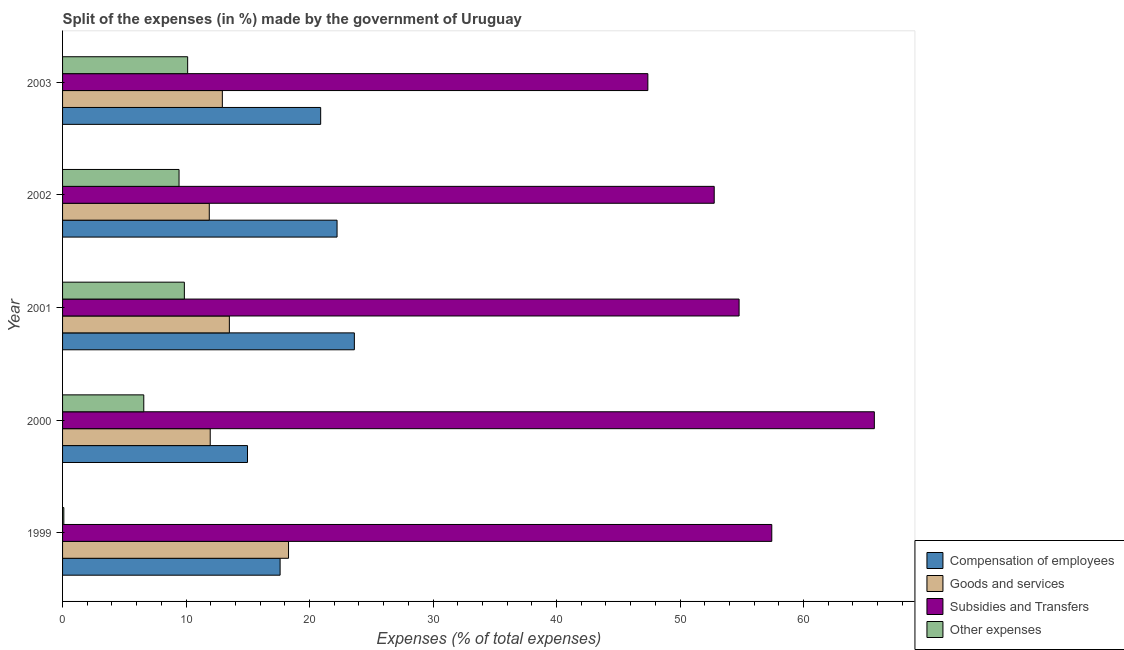How many groups of bars are there?
Your answer should be very brief. 5. Are the number of bars per tick equal to the number of legend labels?
Make the answer very short. Yes. How many bars are there on the 4th tick from the top?
Provide a short and direct response. 4. What is the label of the 2nd group of bars from the top?
Ensure brevity in your answer.  2002. In how many cases, is the number of bars for a given year not equal to the number of legend labels?
Make the answer very short. 0. What is the percentage of amount spent on other expenses in 2000?
Offer a terse response. 6.58. Across all years, what is the maximum percentage of amount spent on other expenses?
Make the answer very short. 10.13. Across all years, what is the minimum percentage of amount spent on other expenses?
Offer a very short reply. 0.1. In which year was the percentage of amount spent on goods and services minimum?
Your answer should be compact. 2002. What is the total percentage of amount spent on compensation of employees in the graph?
Give a very brief answer. 99.34. What is the difference between the percentage of amount spent on goods and services in 2000 and that in 2001?
Keep it short and to the point. -1.55. What is the difference between the percentage of amount spent on other expenses in 2000 and the percentage of amount spent on compensation of employees in 2002?
Offer a terse response. -15.65. What is the average percentage of amount spent on compensation of employees per year?
Your answer should be very brief. 19.87. In the year 2002, what is the difference between the percentage of amount spent on compensation of employees and percentage of amount spent on other expenses?
Keep it short and to the point. 12.79. Is the difference between the percentage of amount spent on goods and services in 1999 and 2003 greater than the difference between the percentage of amount spent on other expenses in 1999 and 2003?
Keep it short and to the point. Yes. What is the difference between the highest and the second highest percentage of amount spent on compensation of employees?
Make the answer very short. 1.4. What is the difference between the highest and the lowest percentage of amount spent on compensation of employees?
Offer a very short reply. 8.65. What does the 4th bar from the top in 2002 represents?
Provide a succinct answer. Compensation of employees. What does the 2nd bar from the bottom in 2000 represents?
Provide a succinct answer. Goods and services. How many bars are there?
Your answer should be very brief. 20. Are all the bars in the graph horizontal?
Keep it short and to the point. Yes. Are the values on the major ticks of X-axis written in scientific E-notation?
Your answer should be very brief. No. Does the graph contain any zero values?
Your answer should be compact. No. Does the graph contain grids?
Provide a short and direct response. No. Where does the legend appear in the graph?
Provide a short and direct response. Bottom right. How are the legend labels stacked?
Make the answer very short. Vertical. What is the title of the graph?
Keep it short and to the point. Split of the expenses (in %) made by the government of Uruguay. What is the label or title of the X-axis?
Ensure brevity in your answer.  Expenses (% of total expenses). What is the Expenses (% of total expenses) of Compensation of employees in 1999?
Ensure brevity in your answer.  17.61. What is the Expenses (% of total expenses) of Goods and services in 1999?
Ensure brevity in your answer.  18.3. What is the Expenses (% of total expenses) in Subsidies and Transfers in 1999?
Provide a succinct answer. 57.43. What is the Expenses (% of total expenses) in Other expenses in 1999?
Your answer should be very brief. 0.1. What is the Expenses (% of total expenses) of Compensation of employees in 2000?
Keep it short and to the point. 14.97. What is the Expenses (% of total expenses) of Goods and services in 2000?
Your response must be concise. 11.96. What is the Expenses (% of total expenses) of Subsidies and Transfers in 2000?
Provide a short and direct response. 65.73. What is the Expenses (% of total expenses) of Other expenses in 2000?
Ensure brevity in your answer.  6.58. What is the Expenses (% of total expenses) of Compensation of employees in 2001?
Offer a very short reply. 23.63. What is the Expenses (% of total expenses) of Goods and services in 2001?
Your answer should be very brief. 13.51. What is the Expenses (% of total expenses) in Subsidies and Transfers in 2001?
Give a very brief answer. 54.78. What is the Expenses (% of total expenses) of Other expenses in 2001?
Offer a terse response. 9.86. What is the Expenses (% of total expenses) in Compensation of employees in 2002?
Ensure brevity in your answer.  22.23. What is the Expenses (% of total expenses) of Goods and services in 2002?
Keep it short and to the point. 11.88. What is the Expenses (% of total expenses) in Subsidies and Transfers in 2002?
Make the answer very short. 52.77. What is the Expenses (% of total expenses) of Other expenses in 2002?
Make the answer very short. 9.43. What is the Expenses (% of total expenses) in Compensation of employees in 2003?
Your answer should be compact. 20.9. What is the Expenses (% of total expenses) of Goods and services in 2003?
Provide a succinct answer. 12.94. What is the Expenses (% of total expenses) in Subsidies and Transfers in 2003?
Provide a short and direct response. 47.39. What is the Expenses (% of total expenses) in Other expenses in 2003?
Provide a succinct answer. 10.13. Across all years, what is the maximum Expenses (% of total expenses) of Compensation of employees?
Provide a succinct answer. 23.63. Across all years, what is the maximum Expenses (% of total expenses) in Goods and services?
Offer a very short reply. 18.3. Across all years, what is the maximum Expenses (% of total expenses) of Subsidies and Transfers?
Your answer should be compact. 65.73. Across all years, what is the maximum Expenses (% of total expenses) of Other expenses?
Offer a very short reply. 10.13. Across all years, what is the minimum Expenses (% of total expenses) of Compensation of employees?
Make the answer very short. 14.97. Across all years, what is the minimum Expenses (% of total expenses) of Goods and services?
Your answer should be compact. 11.88. Across all years, what is the minimum Expenses (% of total expenses) of Subsidies and Transfers?
Your answer should be very brief. 47.39. Across all years, what is the minimum Expenses (% of total expenses) in Other expenses?
Ensure brevity in your answer.  0.1. What is the total Expenses (% of total expenses) in Compensation of employees in the graph?
Your response must be concise. 99.34. What is the total Expenses (% of total expenses) of Goods and services in the graph?
Provide a short and direct response. 68.58. What is the total Expenses (% of total expenses) in Subsidies and Transfers in the graph?
Offer a very short reply. 278.09. What is the total Expenses (% of total expenses) of Other expenses in the graph?
Your answer should be very brief. 36.1. What is the difference between the Expenses (% of total expenses) of Compensation of employees in 1999 and that in 2000?
Provide a short and direct response. 2.64. What is the difference between the Expenses (% of total expenses) in Goods and services in 1999 and that in 2000?
Ensure brevity in your answer.  6.34. What is the difference between the Expenses (% of total expenses) in Subsidies and Transfers in 1999 and that in 2000?
Make the answer very short. -8.3. What is the difference between the Expenses (% of total expenses) of Other expenses in 1999 and that in 2000?
Your answer should be very brief. -6.47. What is the difference between the Expenses (% of total expenses) of Compensation of employees in 1999 and that in 2001?
Provide a succinct answer. -6.01. What is the difference between the Expenses (% of total expenses) in Goods and services in 1999 and that in 2001?
Offer a terse response. 4.79. What is the difference between the Expenses (% of total expenses) in Subsidies and Transfers in 1999 and that in 2001?
Your answer should be very brief. 2.65. What is the difference between the Expenses (% of total expenses) in Other expenses in 1999 and that in 2001?
Give a very brief answer. -9.76. What is the difference between the Expenses (% of total expenses) in Compensation of employees in 1999 and that in 2002?
Provide a succinct answer. -4.61. What is the difference between the Expenses (% of total expenses) of Goods and services in 1999 and that in 2002?
Your answer should be very brief. 6.42. What is the difference between the Expenses (% of total expenses) of Subsidies and Transfers in 1999 and that in 2002?
Provide a succinct answer. 4.66. What is the difference between the Expenses (% of total expenses) in Other expenses in 1999 and that in 2002?
Your answer should be compact. -9.33. What is the difference between the Expenses (% of total expenses) of Compensation of employees in 1999 and that in 2003?
Offer a terse response. -3.29. What is the difference between the Expenses (% of total expenses) of Goods and services in 1999 and that in 2003?
Offer a terse response. 5.36. What is the difference between the Expenses (% of total expenses) in Subsidies and Transfers in 1999 and that in 2003?
Ensure brevity in your answer.  10.03. What is the difference between the Expenses (% of total expenses) of Other expenses in 1999 and that in 2003?
Keep it short and to the point. -10.03. What is the difference between the Expenses (% of total expenses) of Compensation of employees in 2000 and that in 2001?
Your answer should be compact. -8.65. What is the difference between the Expenses (% of total expenses) of Goods and services in 2000 and that in 2001?
Offer a very short reply. -1.55. What is the difference between the Expenses (% of total expenses) of Subsidies and Transfers in 2000 and that in 2001?
Make the answer very short. 10.95. What is the difference between the Expenses (% of total expenses) in Other expenses in 2000 and that in 2001?
Your answer should be compact. -3.29. What is the difference between the Expenses (% of total expenses) in Compensation of employees in 2000 and that in 2002?
Offer a very short reply. -7.25. What is the difference between the Expenses (% of total expenses) of Goods and services in 2000 and that in 2002?
Offer a terse response. 0.08. What is the difference between the Expenses (% of total expenses) in Subsidies and Transfers in 2000 and that in 2002?
Provide a short and direct response. 12.96. What is the difference between the Expenses (% of total expenses) in Other expenses in 2000 and that in 2002?
Ensure brevity in your answer.  -2.85. What is the difference between the Expenses (% of total expenses) in Compensation of employees in 2000 and that in 2003?
Your response must be concise. -5.93. What is the difference between the Expenses (% of total expenses) of Goods and services in 2000 and that in 2003?
Make the answer very short. -0.98. What is the difference between the Expenses (% of total expenses) of Subsidies and Transfers in 2000 and that in 2003?
Your answer should be compact. 18.34. What is the difference between the Expenses (% of total expenses) in Other expenses in 2000 and that in 2003?
Provide a short and direct response. -3.55. What is the difference between the Expenses (% of total expenses) in Compensation of employees in 2001 and that in 2002?
Keep it short and to the point. 1.4. What is the difference between the Expenses (% of total expenses) in Goods and services in 2001 and that in 2002?
Your answer should be very brief. 1.63. What is the difference between the Expenses (% of total expenses) of Subsidies and Transfers in 2001 and that in 2002?
Your answer should be very brief. 2.01. What is the difference between the Expenses (% of total expenses) in Other expenses in 2001 and that in 2002?
Provide a short and direct response. 0.43. What is the difference between the Expenses (% of total expenses) in Compensation of employees in 2001 and that in 2003?
Give a very brief answer. 2.73. What is the difference between the Expenses (% of total expenses) in Goods and services in 2001 and that in 2003?
Make the answer very short. 0.57. What is the difference between the Expenses (% of total expenses) of Subsidies and Transfers in 2001 and that in 2003?
Your answer should be very brief. 7.39. What is the difference between the Expenses (% of total expenses) of Other expenses in 2001 and that in 2003?
Your response must be concise. -0.27. What is the difference between the Expenses (% of total expenses) in Compensation of employees in 2002 and that in 2003?
Provide a succinct answer. 1.33. What is the difference between the Expenses (% of total expenses) in Goods and services in 2002 and that in 2003?
Offer a very short reply. -1.06. What is the difference between the Expenses (% of total expenses) in Subsidies and Transfers in 2002 and that in 2003?
Offer a terse response. 5.37. What is the difference between the Expenses (% of total expenses) in Other expenses in 2002 and that in 2003?
Give a very brief answer. -0.7. What is the difference between the Expenses (% of total expenses) of Compensation of employees in 1999 and the Expenses (% of total expenses) of Goods and services in 2000?
Offer a terse response. 5.66. What is the difference between the Expenses (% of total expenses) of Compensation of employees in 1999 and the Expenses (% of total expenses) of Subsidies and Transfers in 2000?
Offer a terse response. -48.12. What is the difference between the Expenses (% of total expenses) of Compensation of employees in 1999 and the Expenses (% of total expenses) of Other expenses in 2000?
Your answer should be very brief. 11.04. What is the difference between the Expenses (% of total expenses) of Goods and services in 1999 and the Expenses (% of total expenses) of Subsidies and Transfers in 2000?
Offer a very short reply. -47.43. What is the difference between the Expenses (% of total expenses) in Goods and services in 1999 and the Expenses (% of total expenses) in Other expenses in 2000?
Offer a terse response. 11.72. What is the difference between the Expenses (% of total expenses) of Subsidies and Transfers in 1999 and the Expenses (% of total expenses) of Other expenses in 2000?
Offer a terse response. 50.85. What is the difference between the Expenses (% of total expenses) of Compensation of employees in 1999 and the Expenses (% of total expenses) of Goods and services in 2001?
Provide a short and direct response. 4.11. What is the difference between the Expenses (% of total expenses) of Compensation of employees in 1999 and the Expenses (% of total expenses) of Subsidies and Transfers in 2001?
Provide a succinct answer. -37.17. What is the difference between the Expenses (% of total expenses) in Compensation of employees in 1999 and the Expenses (% of total expenses) in Other expenses in 2001?
Offer a terse response. 7.75. What is the difference between the Expenses (% of total expenses) in Goods and services in 1999 and the Expenses (% of total expenses) in Subsidies and Transfers in 2001?
Make the answer very short. -36.48. What is the difference between the Expenses (% of total expenses) in Goods and services in 1999 and the Expenses (% of total expenses) in Other expenses in 2001?
Provide a short and direct response. 8.44. What is the difference between the Expenses (% of total expenses) in Subsidies and Transfers in 1999 and the Expenses (% of total expenses) in Other expenses in 2001?
Offer a very short reply. 47.56. What is the difference between the Expenses (% of total expenses) of Compensation of employees in 1999 and the Expenses (% of total expenses) of Goods and services in 2002?
Provide a succinct answer. 5.74. What is the difference between the Expenses (% of total expenses) in Compensation of employees in 1999 and the Expenses (% of total expenses) in Subsidies and Transfers in 2002?
Your answer should be very brief. -35.15. What is the difference between the Expenses (% of total expenses) in Compensation of employees in 1999 and the Expenses (% of total expenses) in Other expenses in 2002?
Ensure brevity in your answer.  8.18. What is the difference between the Expenses (% of total expenses) of Goods and services in 1999 and the Expenses (% of total expenses) of Subsidies and Transfers in 2002?
Make the answer very short. -34.47. What is the difference between the Expenses (% of total expenses) in Goods and services in 1999 and the Expenses (% of total expenses) in Other expenses in 2002?
Provide a succinct answer. 8.87. What is the difference between the Expenses (% of total expenses) in Subsidies and Transfers in 1999 and the Expenses (% of total expenses) in Other expenses in 2002?
Make the answer very short. 48. What is the difference between the Expenses (% of total expenses) in Compensation of employees in 1999 and the Expenses (% of total expenses) in Goods and services in 2003?
Provide a succinct answer. 4.68. What is the difference between the Expenses (% of total expenses) of Compensation of employees in 1999 and the Expenses (% of total expenses) of Subsidies and Transfers in 2003?
Give a very brief answer. -29.78. What is the difference between the Expenses (% of total expenses) of Compensation of employees in 1999 and the Expenses (% of total expenses) of Other expenses in 2003?
Give a very brief answer. 7.49. What is the difference between the Expenses (% of total expenses) in Goods and services in 1999 and the Expenses (% of total expenses) in Subsidies and Transfers in 2003?
Offer a terse response. -29.09. What is the difference between the Expenses (% of total expenses) of Goods and services in 1999 and the Expenses (% of total expenses) of Other expenses in 2003?
Your response must be concise. 8.17. What is the difference between the Expenses (% of total expenses) in Subsidies and Transfers in 1999 and the Expenses (% of total expenses) in Other expenses in 2003?
Keep it short and to the point. 47.3. What is the difference between the Expenses (% of total expenses) in Compensation of employees in 2000 and the Expenses (% of total expenses) in Goods and services in 2001?
Make the answer very short. 1.47. What is the difference between the Expenses (% of total expenses) of Compensation of employees in 2000 and the Expenses (% of total expenses) of Subsidies and Transfers in 2001?
Provide a succinct answer. -39.81. What is the difference between the Expenses (% of total expenses) in Compensation of employees in 2000 and the Expenses (% of total expenses) in Other expenses in 2001?
Provide a succinct answer. 5.11. What is the difference between the Expenses (% of total expenses) of Goods and services in 2000 and the Expenses (% of total expenses) of Subsidies and Transfers in 2001?
Offer a very short reply. -42.82. What is the difference between the Expenses (% of total expenses) in Goods and services in 2000 and the Expenses (% of total expenses) in Other expenses in 2001?
Your answer should be compact. 2.09. What is the difference between the Expenses (% of total expenses) of Subsidies and Transfers in 2000 and the Expenses (% of total expenses) of Other expenses in 2001?
Keep it short and to the point. 55.87. What is the difference between the Expenses (% of total expenses) of Compensation of employees in 2000 and the Expenses (% of total expenses) of Goods and services in 2002?
Offer a very short reply. 3.09. What is the difference between the Expenses (% of total expenses) in Compensation of employees in 2000 and the Expenses (% of total expenses) in Subsidies and Transfers in 2002?
Keep it short and to the point. -37.79. What is the difference between the Expenses (% of total expenses) in Compensation of employees in 2000 and the Expenses (% of total expenses) in Other expenses in 2002?
Offer a very short reply. 5.54. What is the difference between the Expenses (% of total expenses) of Goods and services in 2000 and the Expenses (% of total expenses) of Subsidies and Transfers in 2002?
Give a very brief answer. -40.81. What is the difference between the Expenses (% of total expenses) in Goods and services in 2000 and the Expenses (% of total expenses) in Other expenses in 2002?
Offer a very short reply. 2.52. What is the difference between the Expenses (% of total expenses) in Subsidies and Transfers in 2000 and the Expenses (% of total expenses) in Other expenses in 2002?
Your answer should be very brief. 56.3. What is the difference between the Expenses (% of total expenses) of Compensation of employees in 2000 and the Expenses (% of total expenses) of Goods and services in 2003?
Give a very brief answer. 2.04. What is the difference between the Expenses (% of total expenses) of Compensation of employees in 2000 and the Expenses (% of total expenses) of Subsidies and Transfers in 2003?
Provide a short and direct response. -32.42. What is the difference between the Expenses (% of total expenses) of Compensation of employees in 2000 and the Expenses (% of total expenses) of Other expenses in 2003?
Offer a very short reply. 4.84. What is the difference between the Expenses (% of total expenses) of Goods and services in 2000 and the Expenses (% of total expenses) of Subsidies and Transfers in 2003?
Your response must be concise. -35.44. What is the difference between the Expenses (% of total expenses) of Goods and services in 2000 and the Expenses (% of total expenses) of Other expenses in 2003?
Provide a succinct answer. 1.83. What is the difference between the Expenses (% of total expenses) in Subsidies and Transfers in 2000 and the Expenses (% of total expenses) in Other expenses in 2003?
Your answer should be very brief. 55.6. What is the difference between the Expenses (% of total expenses) of Compensation of employees in 2001 and the Expenses (% of total expenses) of Goods and services in 2002?
Your response must be concise. 11.75. What is the difference between the Expenses (% of total expenses) in Compensation of employees in 2001 and the Expenses (% of total expenses) in Subsidies and Transfers in 2002?
Offer a terse response. -29.14. What is the difference between the Expenses (% of total expenses) in Compensation of employees in 2001 and the Expenses (% of total expenses) in Other expenses in 2002?
Your response must be concise. 14.2. What is the difference between the Expenses (% of total expenses) of Goods and services in 2001 and the Expenses (% of total expenses) of Subsidies and Transfers in 2002?
Your answer should be very brief. -39.26. What is the difference between the Expenses (% of total expenses) in Goods and services in 2001 and the Expenses (% of total expenses) in Other expenses in 2002?
Your response must be concise. 4.07. What is the difference between the Expenses (% of total expenses) of Subsidies and Transfers in 2001 and the Expenses (% of total expenses) of Other expenses in 2002?
Ensure brevity in your answer.  45.35. What is the difference between the Expenses (% of total expenses) of Compensation of employees in 2001 and the Expenses (% of total expenses) of Goods and services in 2003?
Your answer should be compact. 10.69. What is the difference between the Expenses (% of total expenses) of Compensation of employees in 2001 and the Expenses (% of total expenses) of Subsidies and Transfers in 2003?
Keep it short and to the point. -23.76. What is the difference between the Expenses (% of total expenses) in Compensation of employees in 2001 and the Expenses (% of total expenses) in Other expenses in 2003?
Give a very brief answer. 13.5. What is the difference between the Expenses (% of total expenses) in Goods and services in 2001 and the Expenses (% of total expenses) in Subsidies and Transfers in 2003?
Your answer should be very brief. -33.89. What is the difference between the Expenses (% of total expenses) in Goods and services in 2001 and the Expenses (% of total expenses) in Other expenses in 2003?
Keep it short and to the point. 3.38. What is the difference between the Expenses (% of total expenses) of Subsidies and Transfers in 2001 and the Expenses (% of total expenses) of Other expenses in 2003?
Offer a terse response. 44.65. What is the difference between the Expenses (% of total expenses) in Compensation of employees in 2002 and the Expenses (% of total expenses) in Goods and services in 2003?
Ensure brevity in your answer.  9.29. What is the difference between the Expenses (% of total expenses) in Compensation of employees in 2002 and the Expenses (% of total expenses) in Subsidies and Transfers in 2003?
Ensure brevity in your answer.  -25.17. What is the difference between the Expenses (% of total expenses) in Compensation of employees in 2002 and the Expenses (% of total expenses) in Other expenses in 2003?
Offer a very short reply. 12.1. What is the difference between the Expenses (% of total expenses) of Goods and services in 2002 and the Expenses (% of total expenses) of Subsidies and Transfers in 2003?
Your response must be concise. -35.51. What is the difference between the Expenses (% of total expenses) in Goods and services in 2002 and the Expenses (% of total expenses) in Other expenses in 2003?
Provide a short and direct response. 1.75. What is the difference between the Expenses (% of total expenses) of Subsidies and Transfers in 2002 and the Expenses (% of total expenses) of Other expenses in 2003?
Offer a very short reply. 42.64. What is the average Expenses (% of total expenses) of Compensation of employees per year?
Provide a succinct answer. 19.87. What is the average Expenses (% of total expenses) in Goods and services per year?
Provide a short and direct response. 13.72. What is the average Expenses (% of total expenses) of Subsidies and Transfers per year?
Give a very brief answer. 55.62. What is the average Expenses (% of total expenses) of Other expenses per year?
Provide a short and direct response. 7.22. In the year 1999, what is the difference between the Expenses (% of total expenses) of Compensation of employees and Expenses (% of total expenses) of Goods and services?
Your answer should be very brief. -0.68. In the year 1999, what is the difference between the Expenses (% of total expenses) of Compensation of employees and Expenses (% of total expenses) of Subsidies and Transfers?
Your answer should be compact. -39.81. In the year 1999, what is the difference between the Expenses (% of total expenses) in Compensation of employees and Expenses (% of total expenses) in Other expenses?
Your answer should be compact. 17.51. In the year 1999, what is the difference between the Expenses (% of total expenses) in Goods and services and Expenses (% of total expenses) in Subsidies and Transfers?
Provide a succinct answer. -39.13. In the year 1999, what is the difference between the Expenses (% of total expenses) of Goods and services and Expenses (% of total expenses) of Other expenses?
Provide a short and direct response. 18.19. In the year 1999, what is the difference between the Expenses (% of total expenses) in Subsidies and Transfers and Expenses (% of total expenses) in Other expenses?
Offer a very short reply. 57.32. In the year 2000, what is the difference between the Expenses (% of total expenses) in Compensation of employees and Expenses (% of total expenses) in Goods and services?
Your answer should be very brief. 3.02. In the year 2000, what is the difference between the Expenses (% of total expenses) in Compensation of employees and Expenses (% of total expenses) in Subsidies and Transfers?
Give a very brief answer. -50.76. In the year 2000, what is the difference between the Expenses (% of total expenses) in Compensation of employees and Expenses (% of total expenses) in Other expenses?
Provide a short and direct response. 8.4. In the year 2000, what is the difference between the Expenses (% of total expenses) of Goods and services and Expenses (% of total expenses) of Subsidies and Transfers?
Your response must be concise. -53.77. In the year 2000, what is the difference between the Expenses (% of total expenses) of Goods and services and Expenses (% of total expenses) of Other expenses?
Your response must be concise. 5.38. In the year 2000, what is the difference between the Expenses (% of total expenses) of Subsidies and Transfers and Expenses (% of total expenses) of Other expenses?
Ensure brevity in your answer.  59.15. In the year 2001, what is the difference between the Expenses (% of total expenses) of Compensation of employees and Expenses (% of total expenses) of Goods and services?
Your answer should be compact. 10.12. In the year 2001, what is the difference between the Expenses (% of total expenses) of Compensation of employees and Expenses (% of total expenses) of Subsidies and Transfers?
Ensure brevity in your answer.  -31.15. In the year 2001, what is the difference between the Expenses (% of total expenses) of Compensation of employees and Expenses (% of total expenses) of Other expenses?
Your answer should be very brief. 13.77. In the year 2001, what is the difference between the Expenses (% of total expenses) of Goods and services and Expenses (% of total expenses) of Subsidies and Transfers?
Offer a very short reply. -41.27. In the year 2001, what is the difference between the Expenses (% of total expenses) of Goods and services and Expenses (% of total expenses) of Other expenses?
Your answer should be compact. 3.64. In the year 2001, what is the difference between the Expenses (% of total expenses) in Subsidies and Transfers and Expenses (% of total expenses) in Other expenses?
Offer a terse response. 44.92. In the year 2002, what is the difference between the Expenses (% of total expenses) of Compensation of employees and Expenses (% of total expenses) of Goods and services?
Provide a short and direct response. 10.35. In the year 2002, what is the difference between the Expenses (% of total expenses) in Compensation of employees and Expenses (% of total expenses) in Subsidies and Transfers?
Give a very brief answer. -30.54. In the year 2002, what is the difference between the Expenses (% of total expenses) in Compensation of employees and Expenses (% of total expenses) in Other expenses?
Ensure brevity in your answer.  12.79. In the year 2002, what is the difference between the Expenses (% of total expenses) of Goods and services and Expenses (% of total expenses) of Subsidies and Transfers?
Provide a succinct answer. -40.89. In the year 2002, what is the difference between the Expenses (% of total expenses) in Goods and services and Expenses (% of total expenses) in Other expenses?
Provide a short and direct response. 2.45. In the year 2002, what is the difference between the Expenses (% of total expenses) in Subsidies and Transfers and Expenses (% of total expenses) in Other expenses?
Your response must be concise. 43.33. In the year 2003, what is the difference between the Expenses (% of total expenses) in Compensation of employees and Expenses (% of total expenses) in Goods and services?
Offer a very short reply. 7.96. In the year 2003, what is the difference between the Expenses (% of total expenses) in Compensation of employees and Expenses (% of total expenses) in Subsidies and Transfers?
Offer a terse response. -26.49. In the year 2003, what is the difference between the Expenses (% of total expenses) of Compensation of employees and Expenses (% of total expenses) of Other expenses?
Give a very brief answer. 10.77. In the year 2003, what is the difference between the Expenses (% of total expenses) in Goods and services and Expenses (% of total expenses) in Subsidies and Transfers?
Ensure brevity in your answer.  -34.45. In the year 2003, what is the difference between the Expenses (% of total expenses) of Goods and services and Expenses (% of total expenses) of Other expenses?
Provide a succinct answer. 2.81. In the year 2003, what is the difference between the Expenses (% of total expenses) in Subsidies and Transfers and Expenses (% of total expenses) in Other expenses?
Offer a very short reply. 37.26. What is the ratio of the Expenses (% of total expenses) of Compensation of employees in 1999 to that in 2000?
Provide a short and direct response. 1.18. What is the ratio of the Expenses (% of total expenses) in Goods and services in 1999 to that in 2000?
Give a very brief answer. 1.53. What is the ratio of the Expenses (% of total expenses) of Subsidies and Transfers in 1999 to that in 2000?
Offer a very short reply. 0.87. What is the ratio of the Expenses (% of total expenses) in Other expenses in 1999 to that in 2000?
Your answer should be compact. 0.02. What is the ratio of the Expenses (% of total expenses) in Compensation of employees in 1999 to that in 2001?
Your answer should be very brief. 0.75. What is the ratio of the Expenses (% of total expenses) in Goods and services in 1999 to that in 2001?
Ensure brevity in your answer.  1.35. What is the ratio of the Expenses (% of total expenses) in Subsidies and Transfers in 1999 to that in 2001?
Your answer should be very brief. 1.05. What is the ratio of the Expenses (% of total expenses) of Other expenses in 1999 to that in 2001?
Keep it short and to the point. 0.01. What is the ratio of the Expenses (% of total expenses) in Compensation of employees in 1999 to that in 2002?
Keep it short and to the point. 0.79. What is the ratio of the Expenses (% of total expenses) in Goods and services in 1999 to that in 2002?
Make the answer very short. 1.54. What is the ratio of the Expenses (% of total expenses) of Subsidies and Transfers in 1999 to that in 2002?
Make the answer very short. 1.09. What is the ratio of the Expenses (% of total expenses) in Other expenses in 1999 to that in 2002?
Keep it short and to the point. 0.01. What is the ratio of the Expenses (% of total expenses) in Compensation of employees in 1999 to that in 2003?
Make the answer very short. 0.84. What is the ratio of the Expenses (% of total expenses) in Goods and services in 1999 to that in 2003?
Offer a terse response. 1.41. What is the ratio of the Expenses (% of total expenses) of Subsidies and Transfers in 1999 to that in 2003?
Ensure brevity in your answer.  1.21. What is the ratio of the Expenses (% of total expenses) of Other expenses in 1999 to that in 2003?
Keep it short and to the point. 0.01. What is the ratio of the Expenses (% of total expenses) of Compensation of employees in 2000 to that in 2001?
Your answer should be very brief. 0.63. What is the ratio of the Expenses (% of total expenses) of Goods and services in 2000 to that in 2001?
Offer a terse response. 0.89. What is the ratio of the Expenses (% of total expenses) in Subsidies and Transfers in 2000 to that in 2001?
Keep it short and to the point. 1.2. What is the ratio of the Expenses (% of total expenses) of Other expenses in 2000 to that in 2001?
Your response must be concise. 0.67. What is the ratio of the Expenses (% of total expenses) in Compensation of employees in 2000 to that in 2002?
Offer a very short reply. 0.67. What is the ratio of the Expenses (% of total expenses) in Goods and services in 2000 to that in 2002?
Make the answer very short. 1.01. What is the ratio of the Expenses (% of total expenses) in Subsidies and Transfers in 2000 to that in 2002?
Your answer should be compact. 1.25. What is the ratio of the Expenses (% of total expenses) of Other expenses in 2000 to that in 2002?
Provide a succinct answer. 0.7. What is the ratio of the Expenses (% of total expenses) of Compensation of employees in 2000 to that in 2003?
Give a very brief answer. 0.72. What is the ratio of the Expenses (% of total expenses) in Goods and services in 2000 to that in 2003?
Your answer should be compact. 0.92. What is the ratio of the Expenses (% of total expenses) of Subsidies and Transfers in 2000 to that in 2003?
Your response must be concise. 1.39. What is the ratio of the Expenses (% of total expenses) of Other expenses in 2000 to that in 2003?
Make the answer very short. 0.65. What is the ratio of the Expenses (% of total expenses) of Compensation of employees in 2001 to that in 2002?
Offer a very short reply. 1.06. What is the ratio of the Expenses (% of total expenses) in Goods and services in 2001 to that in 2002?
Your answer should be compact. 1.14. What is the ratio of the Expenses (% of total expenses) of Subsidies and Transfers in 2001 to that in 2002?
Keep it short and to the point. 1.04. What is the ratio of the Expenses (% of total expenses) of Other expenses in 2001 to that in 2002?
Keep it short and to the point. 1.05. What is the ratio of the Expenses (% of total expenses) of Compensation of employees in 2001 to that in 2003?
Keep it short and to the point. 1.13. What is the ratio of the Expenses (% of total expenses) of Goods and services in 2001 to that in 2003?
Your answer should be very brief. 1.04. What is the ratio of the Expenses (% of total expenses) of Subsidies and Transfers in 2001 to that in 2003?
Give a very brief answer. 1.16. What is the ratio of the Expenses (% of total expenses) of Other expenses in 2001 to that in 2003?
Provide a short and direct response. 0.97. What is the ratio of the Expenses (% of total expenses) in Compensation of employees in 2002 to that in 2003?
Offer a very short reply. 1.06. What is the ratio of the Expenses (% of total expenses) in Goods and services in 2002 to that in 2003?
Give a very brief answer. 0.92. What is the ratio of the Expenses (% of total expenses) in Subsidies and Transfers in 2002 to that in 2003?
Provide a succinct answer. 1.11. What is the ratio of the Expenses (% of total expenses) in Other expenses in 2002 to that in 2003?
Your response must be concise. 0.93. What is the difference between the highest and the second highest Expenses (% of total expenses) of Compensation of employees?
Provide a succinct answer. 1.4. What is the difference between the highest and the second highest Expenses (% of total expenses) of Goods and services?
Offer a terse response. 4.79. What is the difference between the highest and the second highest Expenses (% of total expenses) of Subsidies and Transfers?
Provide a short and direct response. 8.3. What is the difference between the highest and the second highest Expenses (% of total expenses) of Other expenses?
Your answer should be very brief. 0.27. What is the difference between the highest and the lowest Expenses (% of total expenses) of Compensation of employees?
Provide a succinct answer. 8.65. What is the difference between the highest and the lowest Expenses (% of total expenses) of Goods and services?
Offer a very short reply. 6.42. What is the difference between the highest and the lowest Expenses (% of total expenses) of Subsidies and Transfers?
Keep it short and to the point. 18.34. What is the difference between the highest and the lowest Expenses (% of total expenses) in Other expenses?
Your response must be concise. 10.03. 